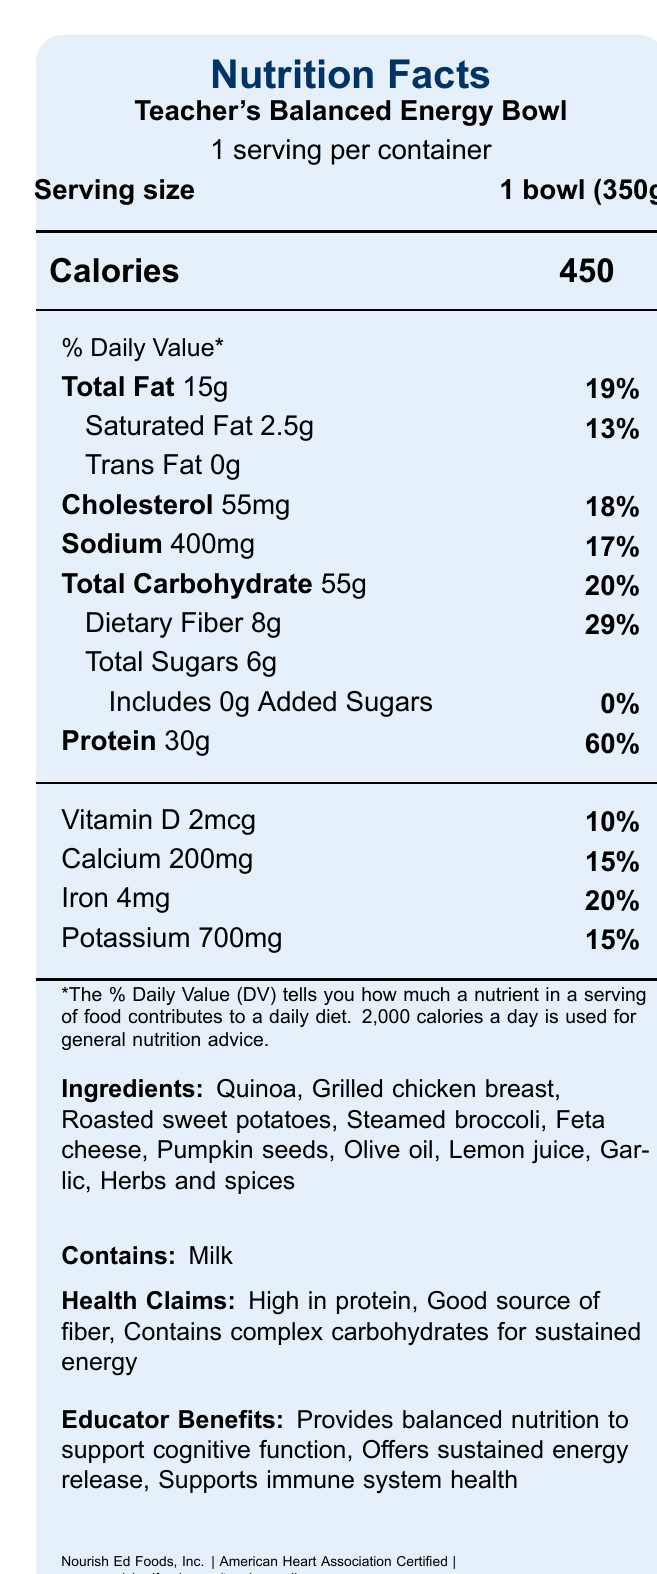what is the serving size? The serving size is listed directly under the product name and alongside "Serving size."
Answer: 1 bowl (350g) how many calories are in one serving of the Teacher's Balanced Energy Bowl? The calorie count is prominently displayed under "Calories."
Answer: 450 what percentage of the Daily Value does the total fat represent? The percentage is provided next to the total fat amount.
Answer: 19% how much dietary fiber does one serving contain? The dietary fiber amount is listed under total carbohydrate information.
Answer: 8g what are the main ingredients in the Teacher's Balanced Energy Bowl? The ingredients are mentioned in detail under the ingredients section.
Answer: Quinoa, Grilled chicken breast, Roasted sweet potatoes, Steamed broccoli, Feta cheese, Pumpkin seeds, Olive oil, Lemon juice, Garlic, Herbs and spices which of the following is a health claim made about the product? A. Low in fat B. High in protein C. Sugar-free The document lists "High in protein" as one of the health claims.
Answer: B how long should you heat the bowl in the microwave if you prefer it hot? A. 1-2 minutes B. 2-3 minutes C. 3-4 minutes The preparation instructions specify heating in a microwave for 2-3 minutes.
Answer: B is the Teacher's Balanced Energy Bowl high in cholesterol? Yes/No With only 18% of the daily value, the cholesterol level is not considered high.
Answer: No describe the main idea of the document. The document outlines the nutritional profile, claims, preparation, and instructions related to a balanced meal option aimed at teachers.
Answer: The document is a Nutrition Facts Label for the Teacher's Balanced Energy Bowl, providing detailed nutritional information, ingredient list, health claims, educator benefits, preparation instructions, and sustainable packaging information. what is the brand that manufactures the Teacher's Balanced Energy Bowl? The manufacturer's name is listed at the bottom of the document.
Answer: Nourish Ed Foods, Inc. are there any added sugars in the Teacher's Balanced Energy Bowl? The document shows 0g of added sugars and 0% daily value for added sugars.
Answer: No how is the packaging of the product described in terms of sustainability? The sustainability note describes the eco-friendly packaging.
Answer: Packaging is made from 100% recycled materials and is fully recyclable which nutrient has the highest daily value percentage? A. Protein B. Calcium C. Iron Protein has the highest daily value percentage at 60%.
Answer: A how often can you consume the product after opening? The storage instructions provide this information.
Answer: Within 3 days of opening what nutrient percentage values can be found for potassium? The document lists the daily value percentage for potassium as 15%.
Answer: 15% what is the website for more information about the Teacher Wellness program? The website is provided at the bottom of the document.
Answer: www.nourishedfoods.com/teacher-wellness is there any soy in the Teacher's Balanced Energy Bowl? The document lists milk as a known allergen but doesn't mention soy, so it's unclear if soy is an ingredient or not.
Answer: Not enough information 